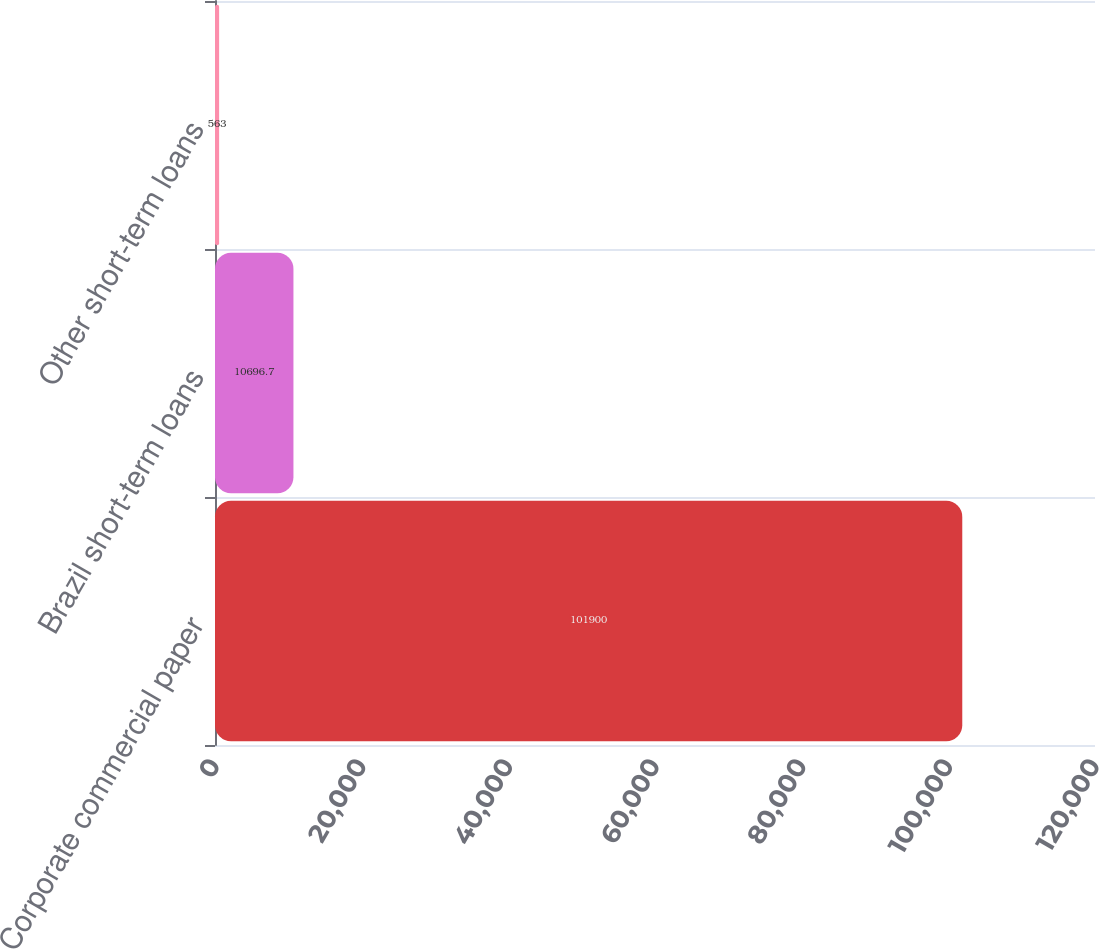<chart> <loc_0><loc_0><loc_500><loc_500><bar_chart><fcel>Corporate commercial paper<fcel>Brazil short-term loans<fcel>Other short-term loans<nl><fcel>101900<fcel>10696.7<fcel>563<nl></chart> 